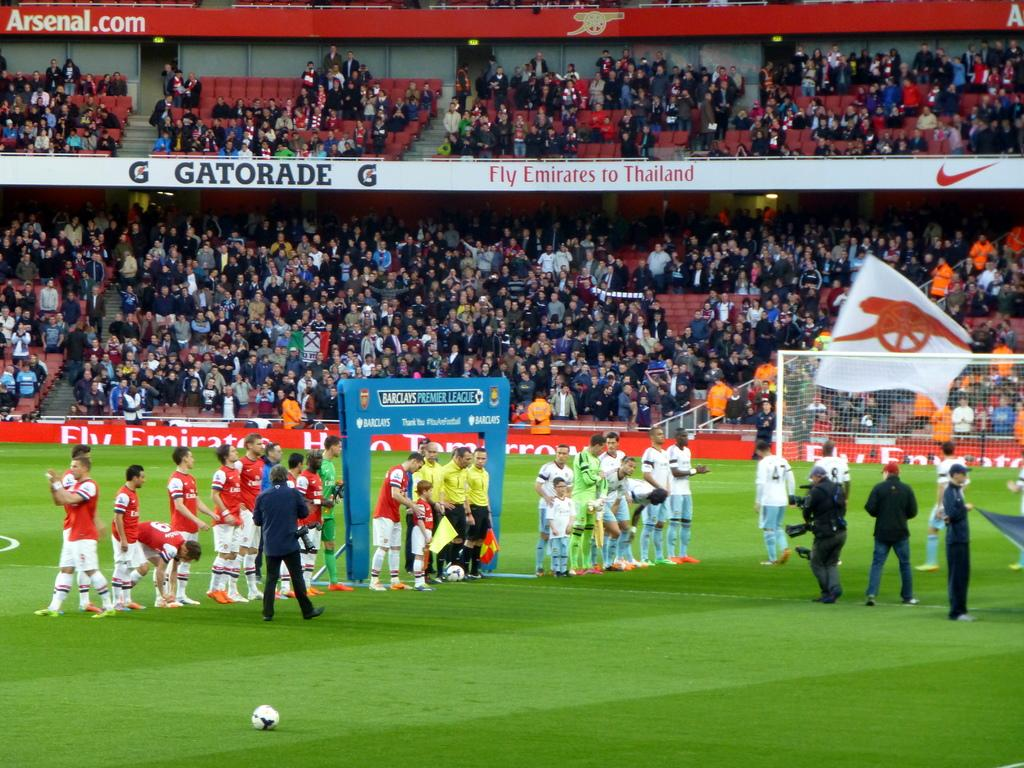<image>
Share a concise interpretation of the image provided. Soccer players on the field near a Barclays Premier League Banner. 